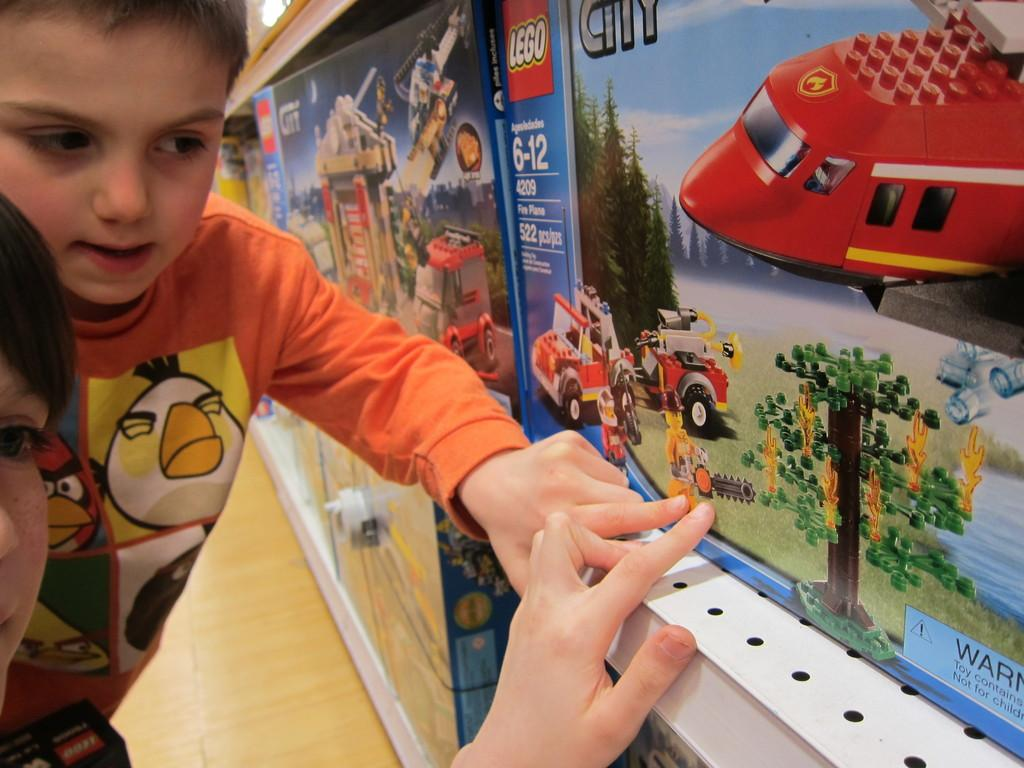<image>
Offer a succinct explanation of the picture presented. Two boys pointing to a box on a shelf of Lego City 